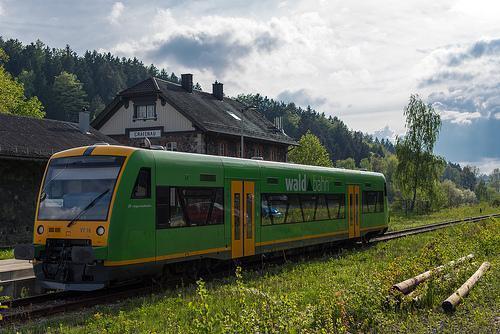How many trains are there?
Give a very brief answer. 1. How many vehicle reflections can you see in the train?
Give a very brief answer. 2. How many chimneys are on the house?
Give a very brief answer. 2. How many sets of doors are on the train?
Give a very brief answer. 2. 